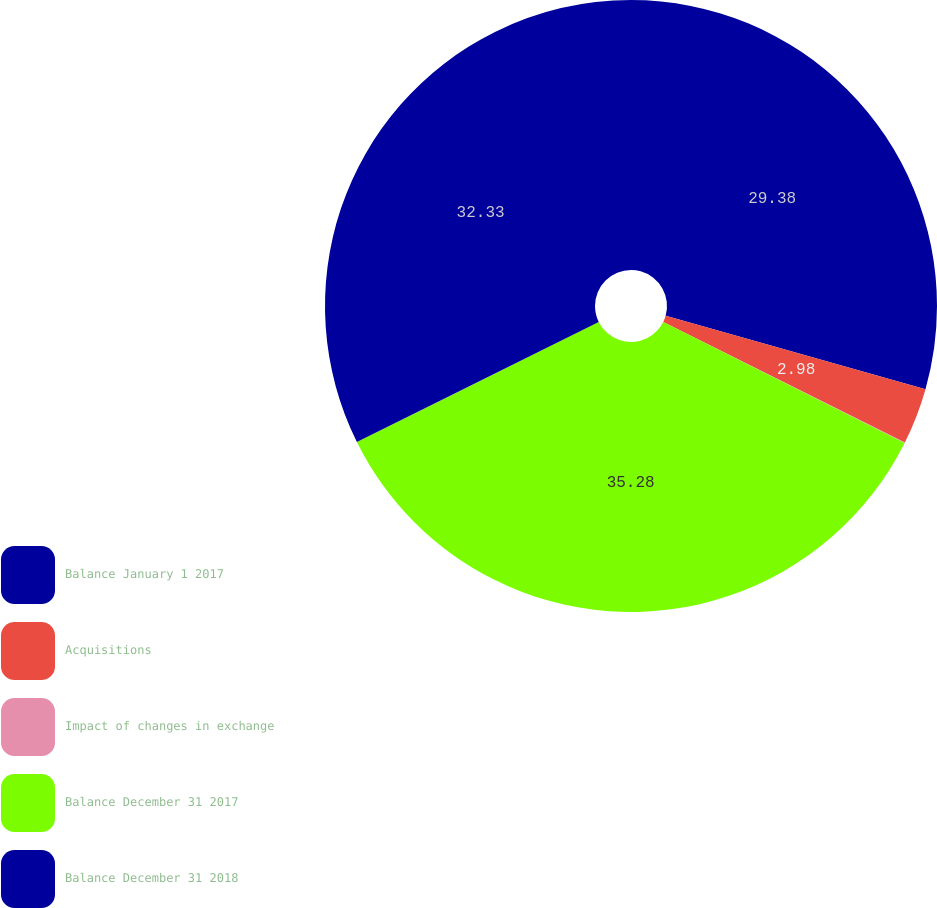Convert chart. <chart><loc_0><loc_0><loc_500><loc_500><pie_chart><fcel>Balance January 1 2017<fcel>Acquisitions<fcel>Impact of changes in exchange<fcel>Balance December 31 2017<fcel>Balance December 31 2018<nl><fcel>29.38%<fcel>2.98%<fcel>0.03%<fcel>35.28%<fcel>32.33%<nl></chart> 